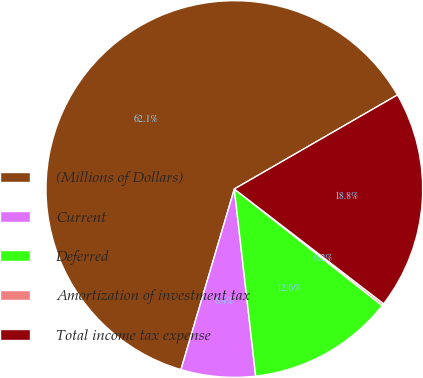<chart> <loc_0><loc_0><loc_500><loc_500><pie_chart><fcel>(Millions of Dollars)<fcel>Current<fcel>Deferred<fcel>Amortization of investment tax<fcel>Total income tax expense<nl><fcel>62.11%<fcel>6.38%<fcel>12.57%<fcel>0.19%<fcel>18.76%<nl></chart> 